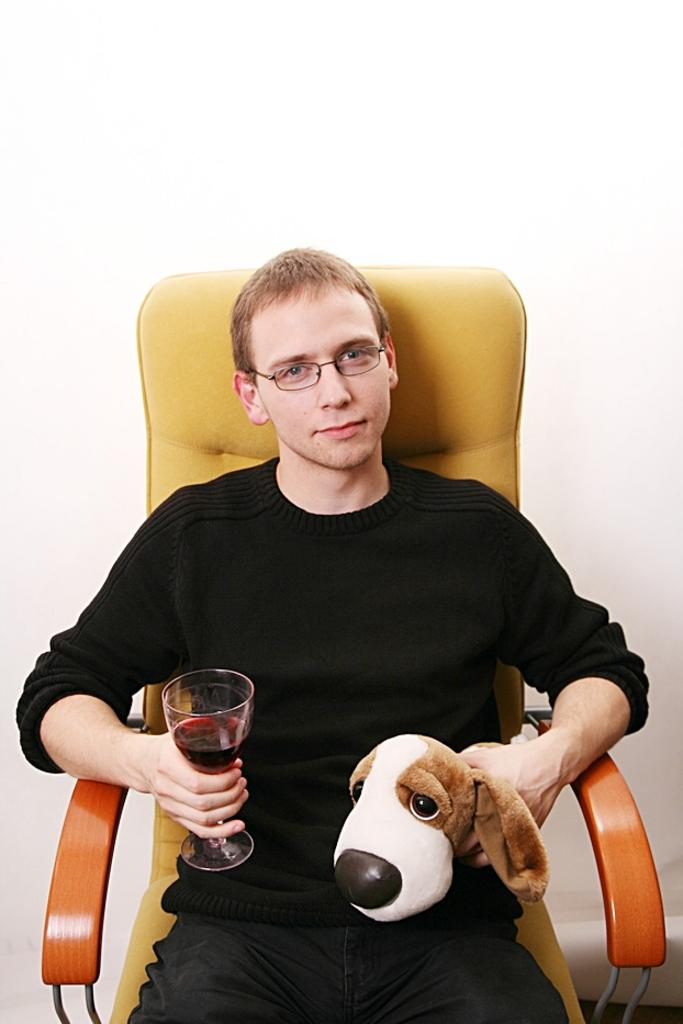Who is present in the image? There is a man in the image. What is the man doing in the image? The man is seated on a chair. What is the man holding in one hand? The man is holding a wine glass in one hand. What is the man holding in the other hand? The man is holding a toy in the other hand. Where is the jail located in the image? There is no jail present in the image. What type of bat is flying around in the image? There is no bat present in the image. 